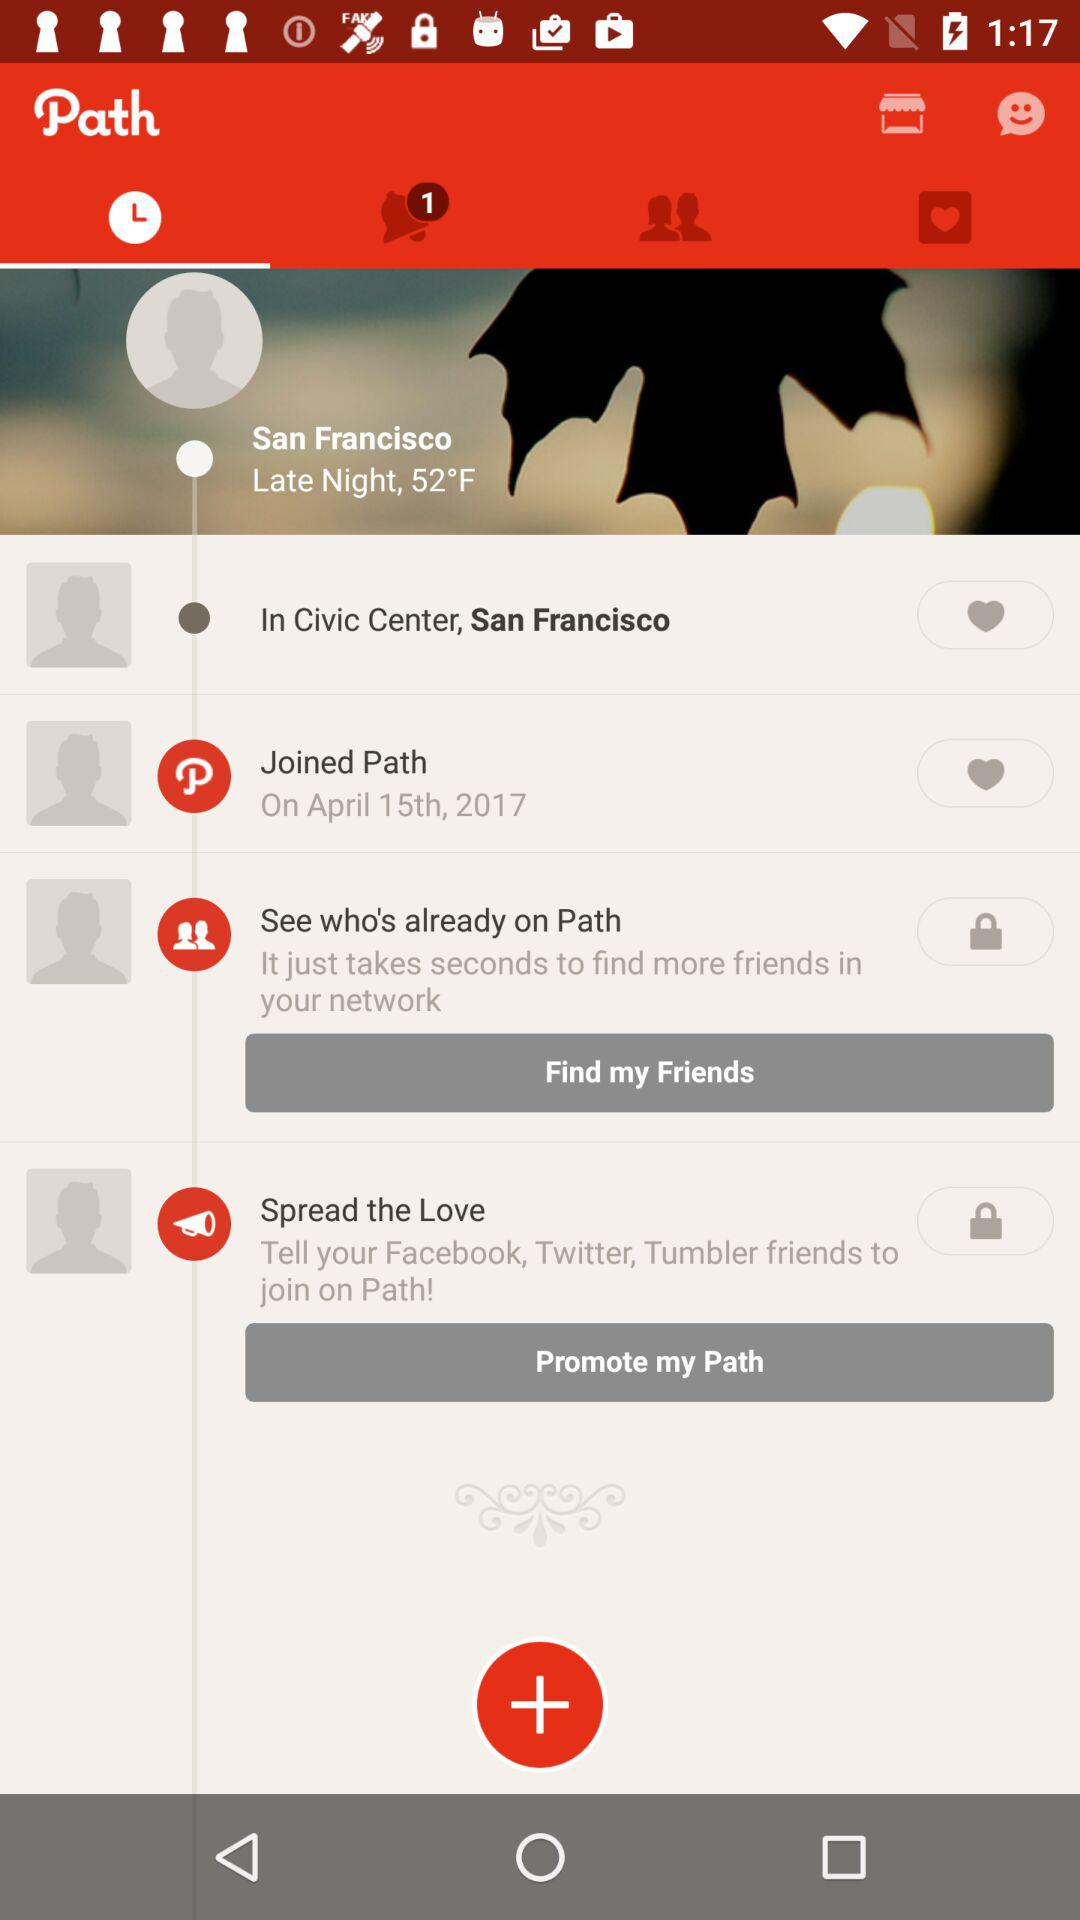How many unread notifications are there? There is 1 unread notification. 